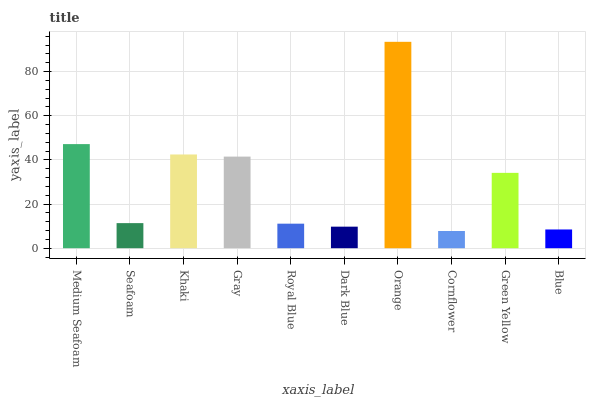Is Cornflower the minimum?
Answer yes or no. Yes. Is Orange the maximum?
Answer yes or no. Yes. Is Seafoam the minimum?
Answer yes or no. No. Is Seafoam the maximum?
Answer yes or no. No. Is Medium Seafoam greater than Seafoam?
Answer yes or no. Yes. Is Seafoam less than Medium Seafoam?
Answer yes or no. Yes. Is Seafoam greater than Medium Seafoam?
Answer yes or no. No. Is Medium Seafoam less than Seafoam?
Answer yes or no. No. Is Green Yellow the high median?
Answer yes or no. Yes. Is Seafoam the low median?
Answer yes or no. Yes. Is Cornflower the high median?
Answer yes or no. No. Is Green Yellow the low median?
Answer yes or no. No. 